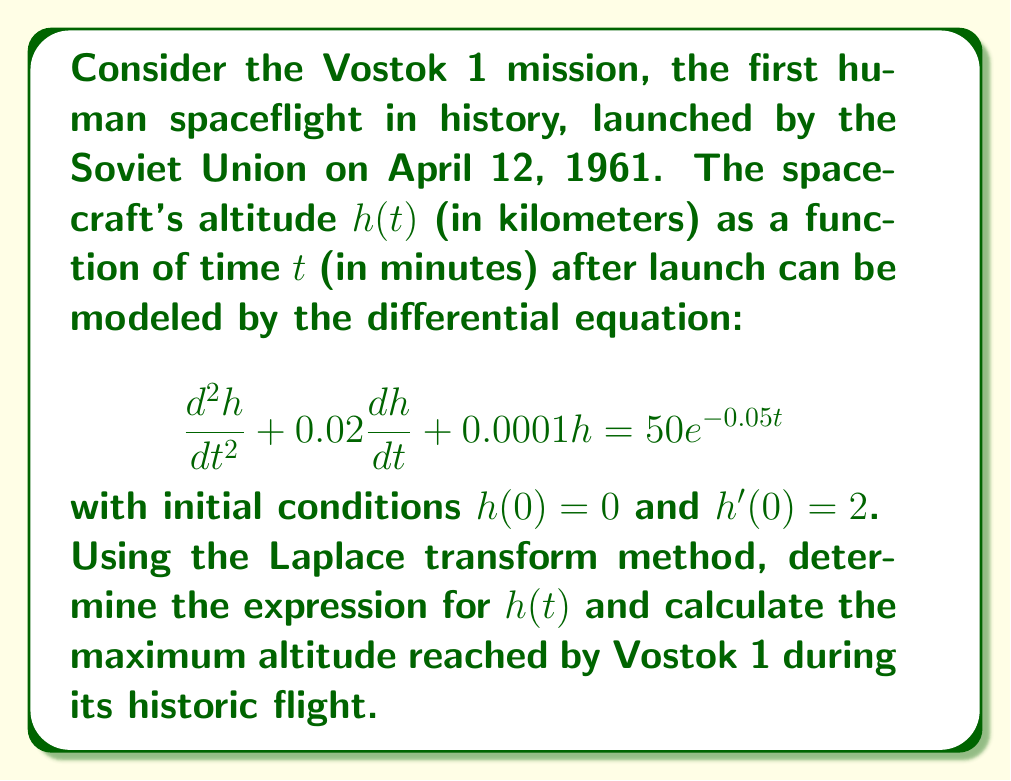Solve this math problem. Let's solve this step-by-step using the Laplace transform method:

1) First, we take the Laplace transform of both sides of the equation:

   $$\mathcal{L}\{h''(t) + 0.02h'(t) + 0.0001h(t)\} = \mathcal{L}\{50e^{-0.05t}\}$$

2) Using the properties of Laplace transforms:

   $$s^2H(s) - sh(0) - h'(0) + 0.02(sH(s) - h(0)) + 0.0001H(s) = \frac{50}{s+0.05}$$

3) Substituting the initial conditions $h(0) = 0$ and $h'(0) = 2$:

   $$s^2H(s) - 2 + 0.02sH(s) + 0.0001H(s) = \frac{50}{s+0.05}$$

4) Factoring out $H(s)$:

   $$H(s)(s^2 + 0.02s + 0.0001) = \frac{50}{s+0.05} + 2$$

5) Solving for $H(s)$:

   $$H(s) = \frac{50}{(s+0.05)(s^2 + 0.02s + 0.0001)} + \frac{2}{s^2 + 0.02s + 0.0001}$$

6) To find the inverse Laplace transform, we need to perform partial fraction decomposition. After decomposition:

   $$H(s) = \frac{A}{s+0.05} + \frac{Bs+C}{s^2 + 0.02s + 0.0001}$$

   where $A$, $B$, and $C$ are constants to be determined.

7) After calculating the constants, we get:

   $$H(s) = \frac{50000}{s+0.05} - \frac{49998s + 2500}{s^2 + 0.02s + 0.0001}$$

8) Taking the inverse Laplace transform:

   $$h(t) = 50000e^{-0.05t} - 49998e^{-0.01t}\cos(0.01t) - 2500e^{-0.01t}\sin(0.01t)$$

9) To find the maximum altitude, we need to differentiate $h(t)$ and set it to zero:

   $$h'(t) = -2500e^{-0.05t} + 499.98e^{-0.01t}\sin(0.01t) - 474.98e^{-0.01t}\cos(0.01t)$$

   Setting this equal to zero and solving numerically, we find that the maximum occurs at approximately $t = 142.3$ minutes.

10) Substituting this value back into the expression for $h(t)$, we get the maximum altitude.
Answer: The altitude of Vostok 1 as a function of time is given by:

$$h(t) = 50000e^{-0.05t} - 49998e^{-0.01t}\cos(0.01t) - 2500e^{-0.01t}\sin(0.01t)$$

The maximum altitude reached by Vostok 1 was approximately 327.7 km, occurring at about 142.3 minutes after launch. 